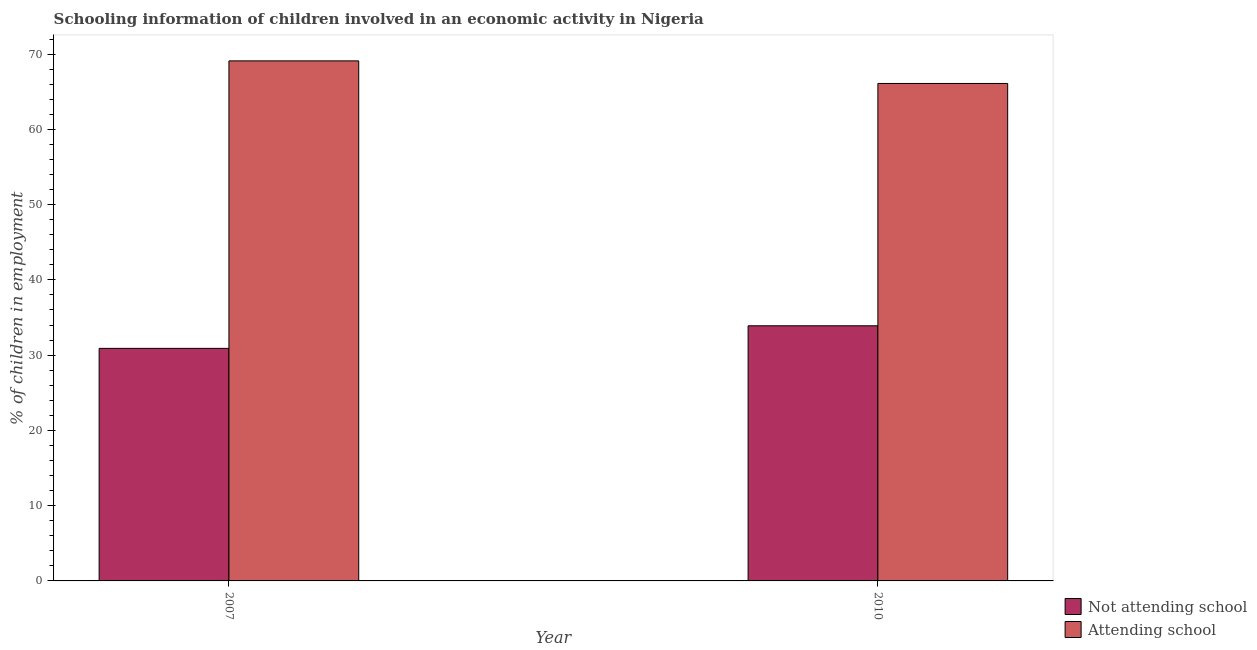How many different coloured bars are there?
Offer a very short reply. 2. How many bars are there on the 1st tick from the left?
Provide a short and direct response. 2. In how many cases, is the number of bars for a given year not equal to the number of legend labels?
Give a very brief answer. 0. What is the percentage of employed children who are not attending school in 2007?
Your response must be concise. 30.9. Across all years, what is the maximum percentage of employed children who are attending school?
Give a very brief answer. 69.1. Across all years, what is the minimum percentage of employed children who are not attending school?
Give a very brief answer. 30.9. In which year was the percentage of employed children who are not attending school minimum?
Your answer should be compact. 2007. What is the total percentage of employed children who are attending school in the graph?
Your answer should be very brief. 135.2. What is the average percentage of employed children who are not attending school per year?
Keep it short and to the point. 32.4. What is the ratio of the percentage of employed children who are not attending school in 2007 to that in 2010?
Give a very brief answer. 0.91. What does the 1st bar from the left in 2007 represents?
Offer a terse response. Not attending school. What does the 1st bar from the right in 2007 represents?
Offer a terse response. Attending school. How many years are there in the graph?
Make the answer very short. 2. Are the values on the major ticks of Y-axis written in scientific E-notation?
Offer a very short reply. No. Does the graph contain any zero values?
Your response must be concise. No. How many legend labels are there?
Ensure brevity in your answer.  2. What is the title of the graph?
Your response must be concise. Schooling information of children involved in an economic activity in Nigeria. Does "By country of asylum" appear as one of the legend labels in the graph?
Your response must be concise. No. What is the label or title of the X-axis?
Your answer should be very brief. Year. What is the label or title of the Y-axis?
Your response must be concise. % of children in employment. What is the % of children in employment in Not attending school in 2007?
Give a very brief answer. 30.9. What is the % of children in employment of Attending school in 2007?
Your answer should be very brief. 69.1. What is the % of children in employment of Not attending school in 2010?
Provide a succinct answer. 33.9. What is the % of children in employment in Attending school in 2010?
Your response must be concise. 66.1. Across all years, what is the maximum % of children in employment in Not attending school?
Make the answer very short. 33.9. Across all years, what is the maximum % of children in employment in Attending school?
Offer a terse response. 69.1. Across all years, what is the minimum % of children in employment in Not attending school?
Provide a short and direct response. 30.9. Across all years, what is the minimum % of children in employment in Attending school?
Give a very brief answer. 66.1. What is the total % of children in employment of Not attending school in the graph?
Offer a very short reply. 64.8. What is the total % of children in employment of Attending school in the graph?
Provide a short and direct response. 135.2. What is the difference between the % of children in employment of Not attending school in 2007 and that in 2010?
Offer a terse response. -3. What is the difference between the % of children in employment of Not attending school in 2007 and the % of children in employment of Attending school in 2010?
Give a very brief answer. -35.2. What is the average % of children in employment of Not attending school per year?
Provide a succinct answer. 32.4. What is the average % of children in employment of Attending school per year?
Give a very brief answer. 67.6. In the year 2007, what is the difference between the % of children in employment of Not attending school and % of children in employment of Attending school?
Make the answer very short. -38.2. In the year 2010, what is the difference between the % of children in employment of Not attending school and % of children in employment of Attending school?
Provide a succinct answer. -32.2. What is the ratio of the % of children in employment in Not attending school in 2007 to that in 2010?
Your response must be concise. 0.91. What is the ratio of the % of children in employment of Attending school in 2007 to that in 2010?
Give a very brief answer. 1.05. What is the difference between the highest and the second highest % of children in employment in Not attending school?
Offer a terse response. 3. What is the difference between the highest and the second highest % of children in employment in Attending school?
Ensure brevity in your answer.  3. 